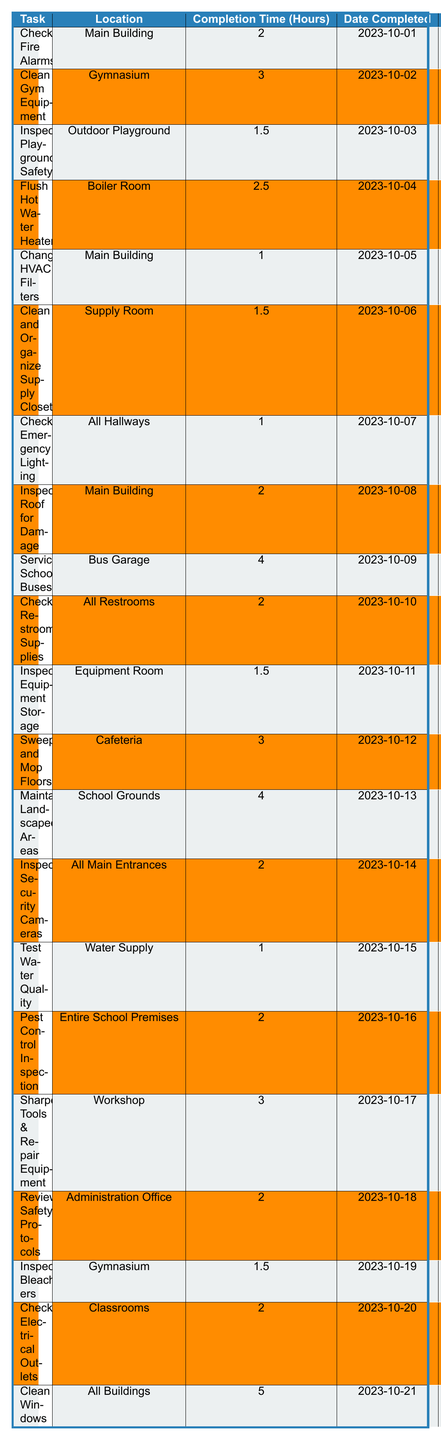What is the task completed on "2023-10-10"? From the table, if we check the "Date Completed" column for the date "2023-10-10", we find the task is "Check Restroom Supplies".
Answer: Check Restroom Supplies How many hours did it take to "Clean Gym Equipment"? Looking at the "Completion Time (Hours)" column next to "Clean Gym Equipment", it shows it took 3 hours to complete this task.
Answer: 3 What is the longest task duration in hours? We need to evaluate all completion times listed in the "Completion Time (Hours)" column. The maximum time is 5 hours, corresponding to "Clean Windows".
Answer: 5 Is "Inspect Playground Safety" completed every month? The table shows that "Inspect Playground Safety" has a frequency of "Monthly," confirming that it is indeed completed every month.
Answer: Yes What is the total time taken for maintenance tasks in the Gymnasium? We find the tasks related to the Gymnasium: "Clean Gym Equipment" (3 hours) and "Inspect Bleachers" (1.5 hours). Adding these gives us 3 + 1.5 = 4.5 hours total.
Answer: 4.5 Which task done in the Main Building took the least time? Checking the "Main Building" tasks, we see "Change HVAC Filters" (1 hour) and "Check Fire Alarms" (2 hours). The lesser time is 1 hour for "Change HVAC Filters".
Answer: Change HVAC Filters How many tasks required more than 2 hours to complete? We’ll check the "Completion Time (Hours)" and count the tasks taking over 2 hours: "Clean Gym Equipment" (3), "Flush Hot Water Heaters" (2.5), "Service School Buses" (4), "Maintain Landscaped Areas" (4), and "Clean Windows" (5). That's a total of 5 tasks.
Answer: 5 What percentage of tasks were completed within 2 hours or less? There are 20 tasks in total. Counting those that took 2 hours or less gives us: "Inspect Playground Safety" (1.5), "Change HVAC Filters" (1), "Check Emergency Lighting" (1), "Test Water Quality" (1), and "Inspect Equipment Storage" (1.5), totaling 5 tasks. The percentage is (5/20) * 100 = 25%.
Answer: 25% Identify the location where the "Service School Buses" task was performed. Looking at the "Location" column for the task "Service School Buses," we find it was performed in the "Bus Garage".
Answer: Bus Garage How many more hours were spent on "Clean Windows" compared to "Check Electrical Outlets"? The "Clean Windows" task took 5 hours while "Check Electrical Outlets" took 2 hours. The difference is 5 - 2 = 3 hours.
Answer: 3 What task on "2023-10-14" required 2 hours? The table shows on "2023-10-14", the task "Inspect Security Cameras" required 2 hours to complete.
Answer: Inspect Security Cameras 